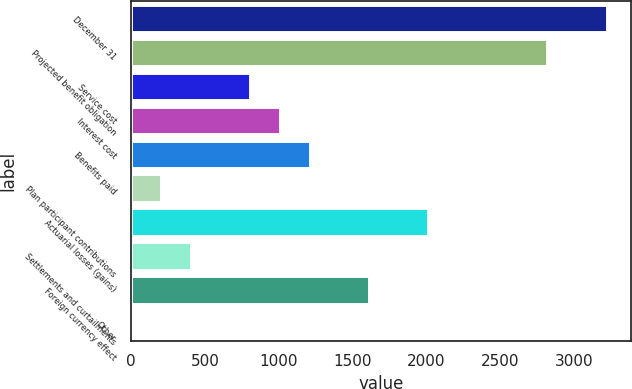Convert chart to OTSL. <chart><loc_0><loc_0><loc_500><loc_500><bar_chart><fcel>December 31<fcel>Projected benefit obligation<fcel>Service cost<fcel>Interest cost<fcel>Benefits paid<fcel>Plan participant contributions<fcel>Actuarial losses (gains)<fcel>Settlements and curtailments<fcel>Foreign currency effect<fcel>Other<nl><fcel>3222.1<fcel>2819.4<fcel>805.9<fcel>1007.25<fcel>1208.6<fcel>201.85<fcel>2014<fcel>403.2<fcel>1611.3<fcel>0.5<nl></chart> 